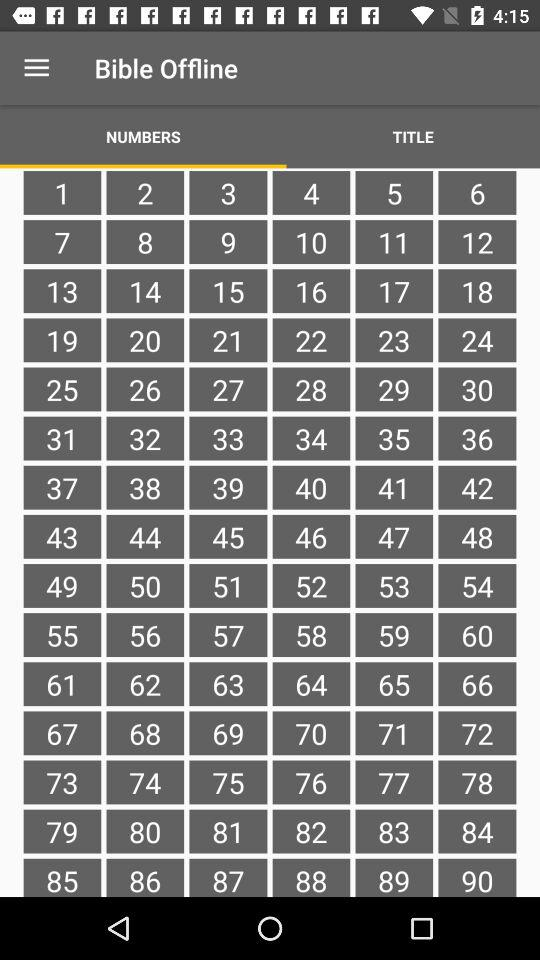What is the name of the application? The name of the application is "Bible Offline". 